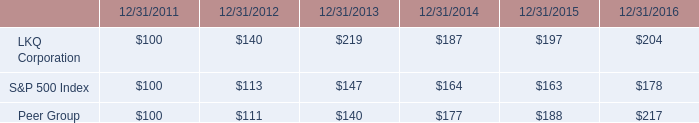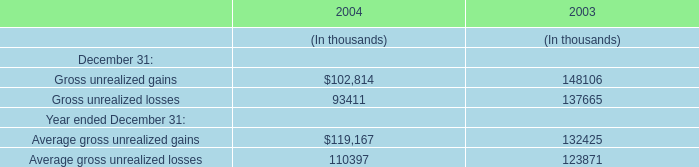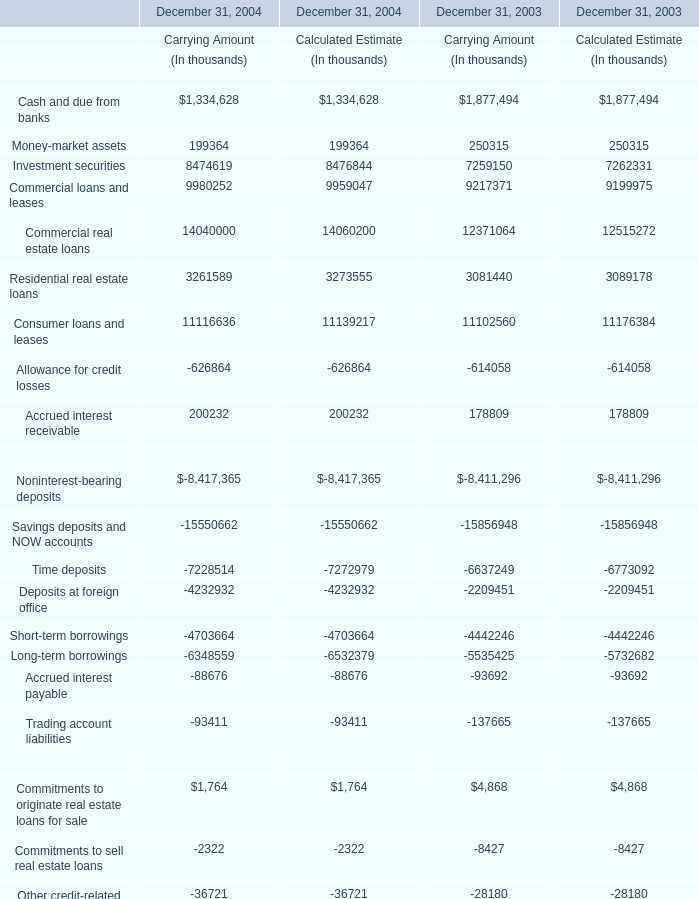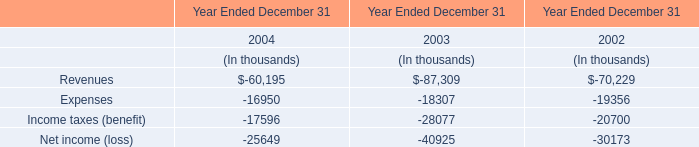What will Investment securities in carrying amount reach in 2005 if it continues to grow at its current rate? (in thousand) 
Computations: ((((8474619 - 7259150) / 7259150) + 1) * 8474619)
Answer: 9893605.61432. 